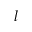Convert formula to latex. <formula><loc_0><loc_0><loc_500><loc_500>l</formula> 